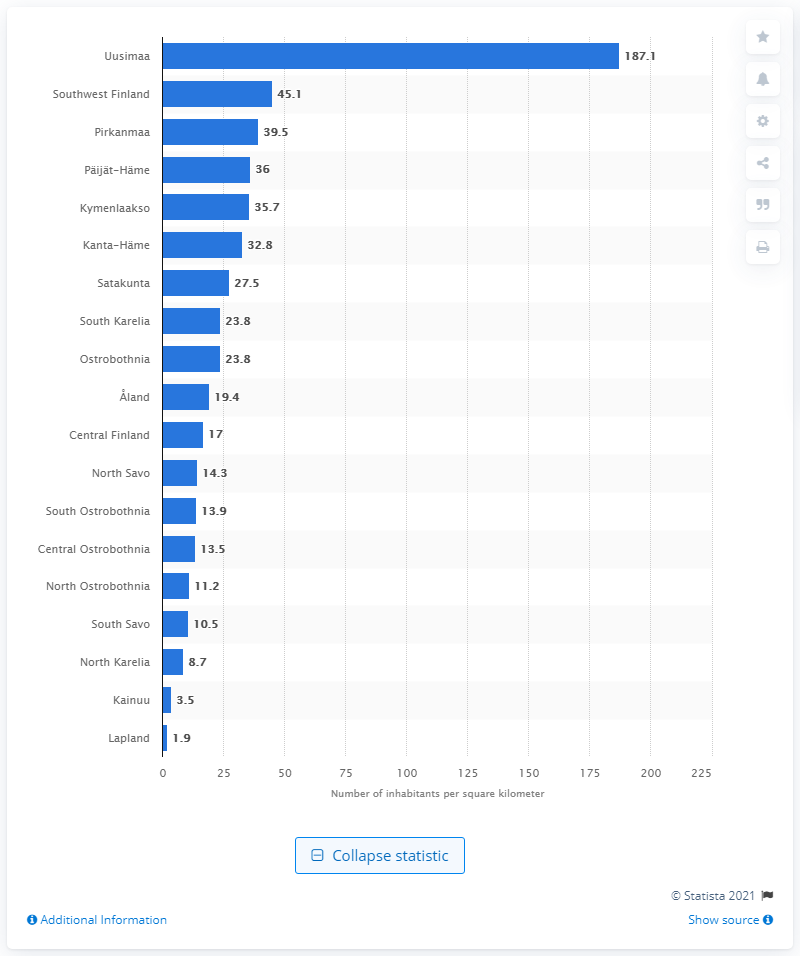Specify some key components in this picture. Uusimaa is the most densely populated region in Finland. Lapland was Finland's most sparsely populated region. 